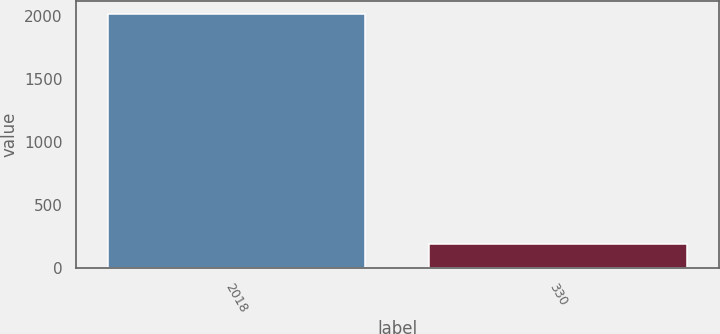<chart> <loc_0><loc_0><loc_500><loc_500><bar_chart><fcel>2018<fcel>330<nl><fcel>2017<fcel>189<nl></chart> 